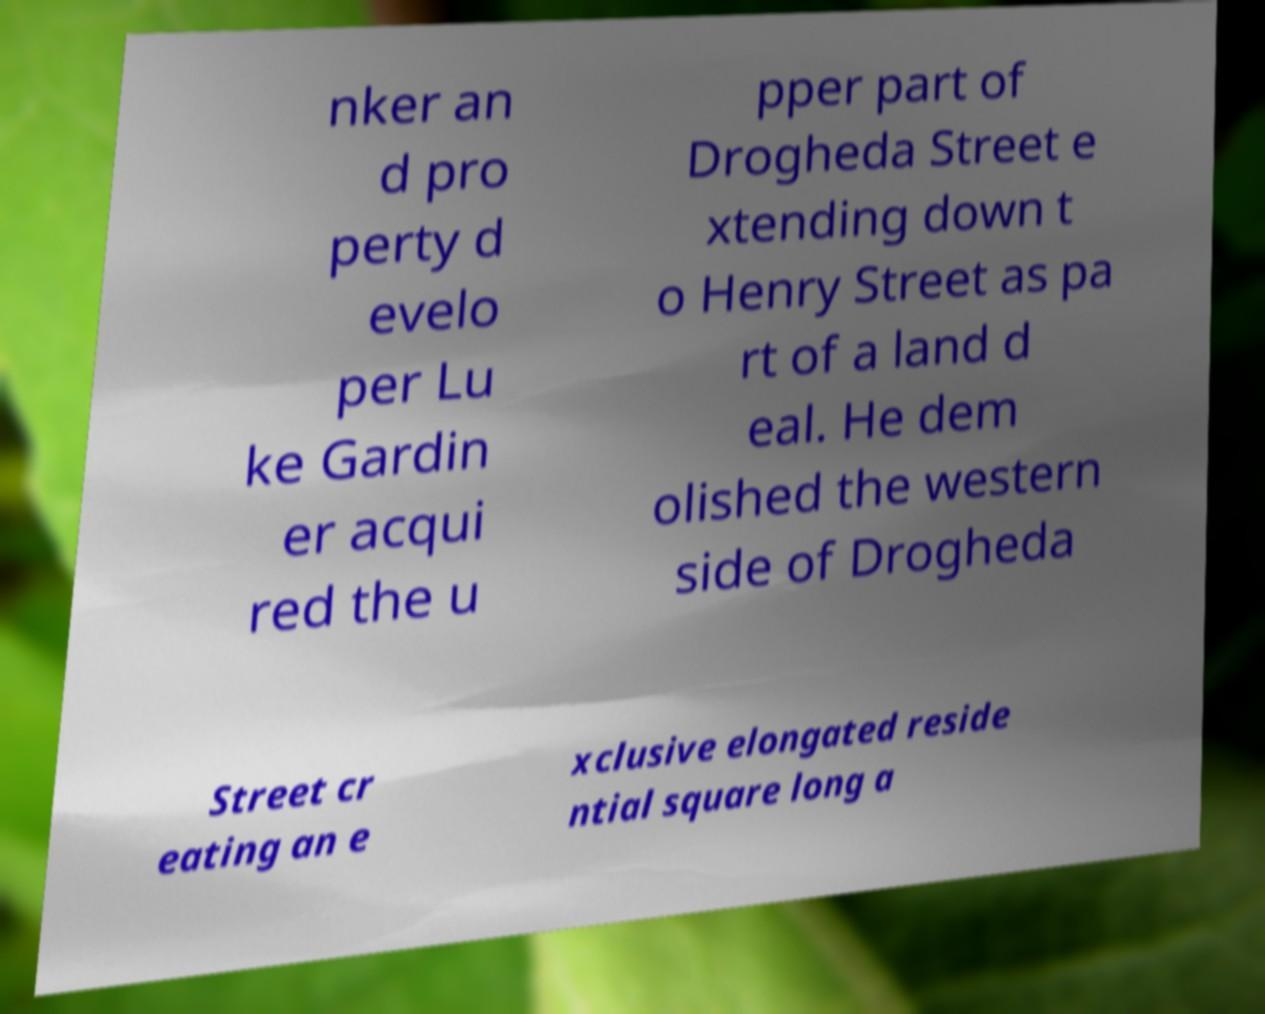What messages or text are displayed in this image? I need them in a readable, typed format. nker an d pro perty d evelo per Lu ke Gardin er acqui red the u pper part of Drogheda Street e xtending down t o Henry Street as pa rt of a land d eal. He dem olished the western side of Drogheda Street cr eating an e xclusive elongated reside ntial square long a 